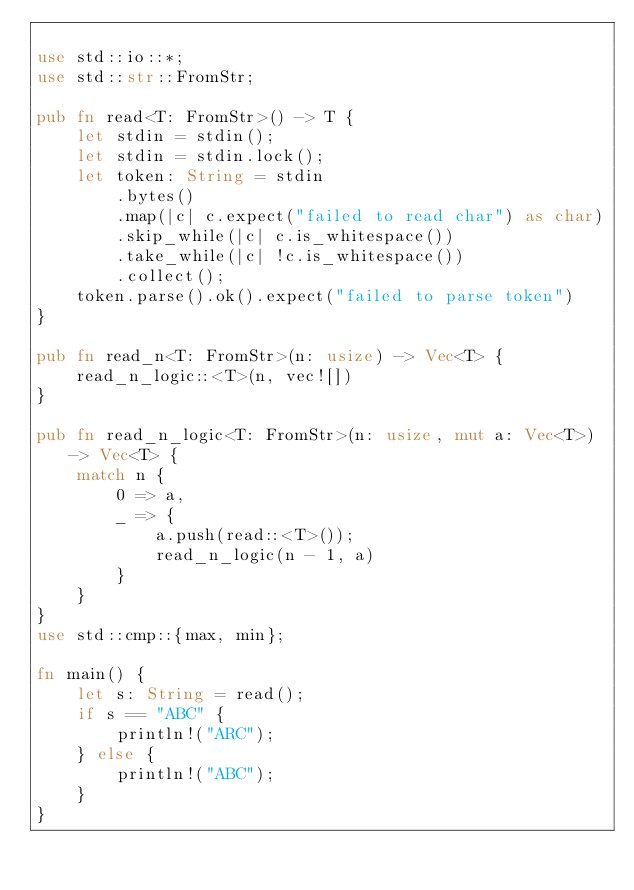<code> <loc_0><loc_0><loc_500><loc_500><_Rust_>
use std::io::*;
use std::str::FromStr;

pub fn read<T: FromStr>() -> T {
    let stdin = stdin();
    let stdin = stdin.lock();
    let token: String = stdin
        .bytes()
        .map(|c| c.expect("failed to read char") as char)
        .skip_while(|c| c.is_whitespace())
        .take_while(|c| !c.is_whitespace())
        .collect();
    token.parse().ok().expect("failed to parse token")
}

pub fn read_n<T: FromStr>(n: usize) -> Vec<T> {
    read_n_logic::<T>(n, vec![])
}

pub fn read_n_logic<T: FromStr>(n: usize, mut a: Vec<T>) -> Vec<T> {
    match n {
        0 => a,
        _ => {
            a.push(read::<T>());
            read_n_logic(n - 1, a)
        }
    }
}
use std::cmp::{max, min};

fn main() {
    let s: String = read();
    if s == "ABC" {
        println!("ARC");
    } else {
        println!("ABC");
    }
}
</code> 